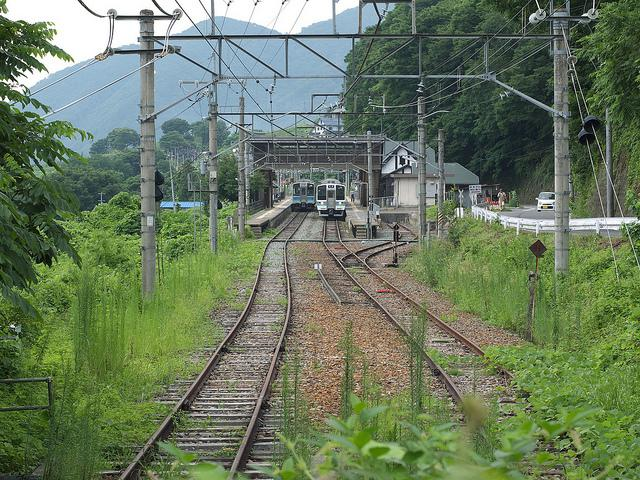How many trains could be traveling underneath of these wires overhanging the train track?

Choices:
A) four
B) three
C) two
D) five two 